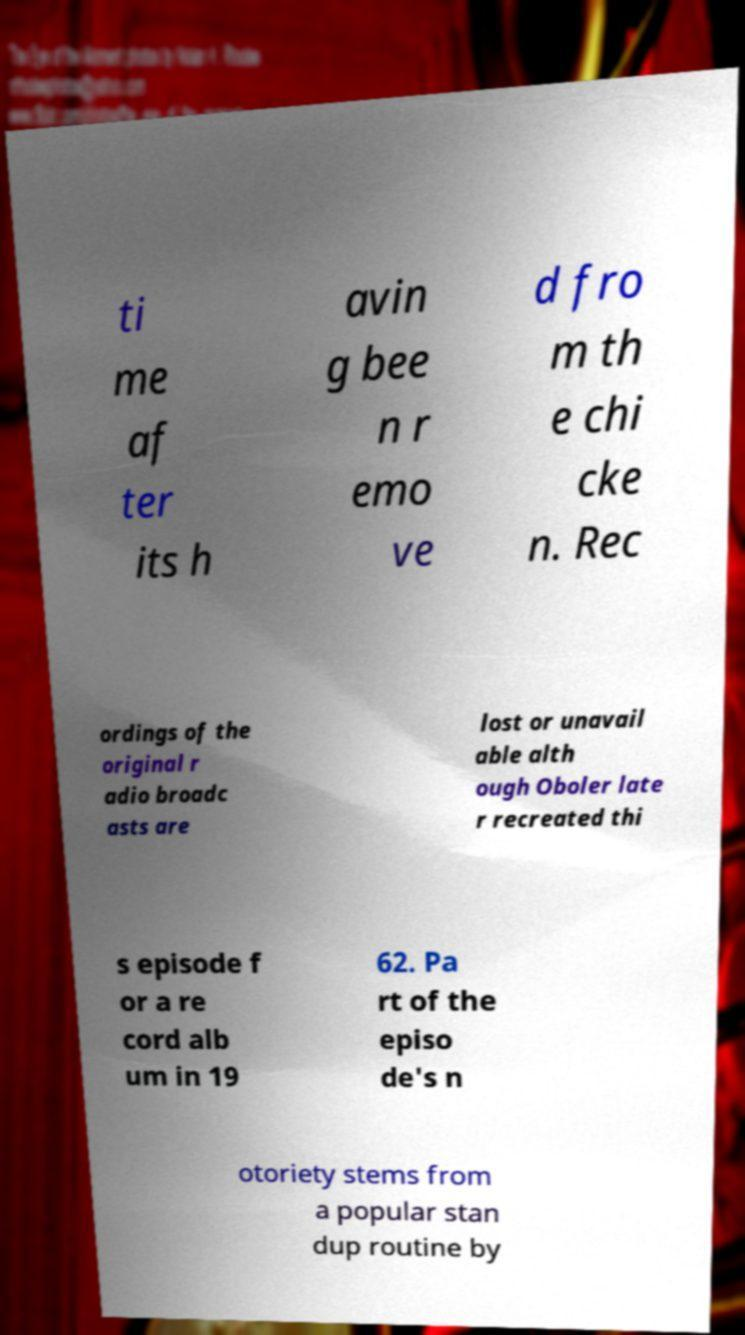Please read and relay the text visible in this image. What does it say? ti me af ter its h avin g bee n r emo ve d fro m th e chi cke n. Rec ordings of the original r adio broadc asts are lost or unavail able alth ough Oboler late r recreated thi s episode f or a re cord alb um in 19 62. Pa rt of the episo de's n otoriety stems from a popular stan dup routine by 